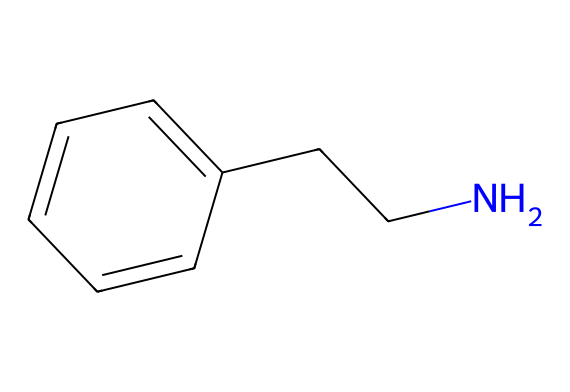What is the molecular formula of phenylethylamine? The molecular formula is determined by counting the number of each type of atom present in the SMILES representation. From the structure, there are 8 carbon atoms (C), 11 hydrogen atoms (H), and 1 nitrogen atom (N), leading to the formula C8H11N.
Answer: C8H11N How many rings are present in phenylethylamine? By analyzing the SMILES representation, we see it contains a benzene ring, which is a six-membered cyclic structure. There are no additional cycles in the remaining part of the molecule. Therefore, there is one ring.
Answer: 1 What type of compound is phenylethylamine? The presence of the nitrogen atom and its structure indicates that phenylethylamine is an amine. Additionally, the aromatic ring classifies it as an aromatic amine.
Answer: aromatic amine Which atom in phenylethylamine contributes to its basicity? The presence of the nitrogen atom is significant for basicity. It has a lone pair of electrons that can accept protons, making the molecule basic. This is typical for amine compounds.
Answer: nitrogen What class of chemical does phenylethylamine belong to and why? Phenylethylamine belongs to the class of substituted amines due to the presence of the amine functional group (–NH) along with the substituent phenyl group (derived from benzene). Together, they classify it as an amine-based compound.
Answer: substituted amines What functional groups are present in phenylethylamine? The molecular structure shows a primary amine group (-NH2) and a phenyl group (C6H5), making these the key functional groups in phenylethylamine.
Answer: amine and phenyl groups 